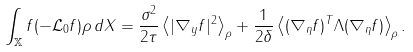<formula> <loc_0><loc_0><loc_500><loc_500>\int _ { \mathbb { X } } f ( - \mathcal { L } _ { 0 } f ) \rho \, d X = \frac { \sigma ^ { 2 } } { 2 \tau } \left \langle | \nabla _ { y } f | ^ { 2 } \right \rangle _ { \rho } + \frac { 1 } { 2 \delta } \left \langle ( \nabla _ { \eta } f ) ^ { T } \Lambda ( \nabla _ { \eta } f ) \right \rangle _ { \rho } .</formula> 